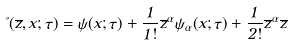Convert formula to latex. <formula><loc_0><loc_0><loc_500><loc_500>\Psi ( \overline { z } , x ; \tau ) = \psi ( x ; \tau ) + \frac { 1 } { 1 ! } \overline { z } ^ { \alpha } \psi _ { \alpha } ( x ; \tau ) + \frac { 1 } { 2 ! } \overline { z } ^ { \alpha } \overline { z }</formula> 